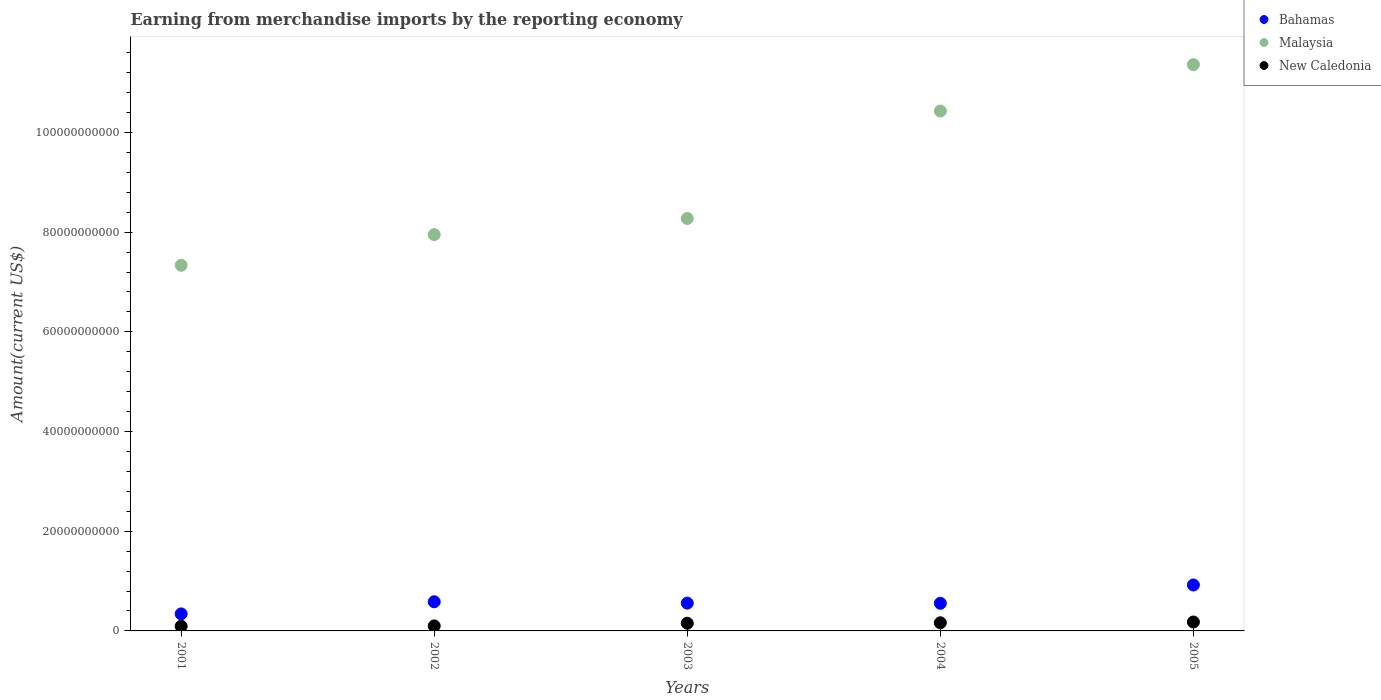Is the number of dotlines equal to the number of legend labels?
Make the answer very short. Yes. What is the amount earned from merchandise imports in New Caledonia in 2002?
Your response must be concise. 1.01e+09. Across all years, what is the maximum amount earned from merchandise imports in Bahamas?
Make the answer very short. 9.22e+09. Across all years, what is the minimum amount earned from merchandise imports in Bahamas?
Make the answer very short. 3.42e+09. In which year was the amount earned from merchandise imports in Bahamas maximum?
Provide a short and direct response. 2005. In which year was the amount earned from merchandise imports in Malaysia minimum?
Offer a very short reply. 2001. What is the total amount earned from merchandise imports in New Caledonia in the graph?
Your answer should be very brief. 6.91e+09. What is the difference between the amount earned from merchandise imports in Malaysia in 2001 and that in 2004?
Provide a succinct answer. -3.09e+1. What is the difference between the amount earned from merchandise imports in New Caledonia in 2002 and the amount earned from merchandise imports in Malaysia in 2003?
Your answer should be very brief. -8.17e+1. What is the average amount earned from merchandise imports in Malaysia per year?
Your response must be concise. 9.07e+1. In the year 2005, what is the difference between the amount earned from merchandise imports in Bahamas and amount earned from merchandise imports in New Caledonia?
Give a very brief answer. 7.43e+09. In how many years, is the amount earned from merchandise imports in Bahamas greater than 104000000000 US$?
Your answer should be compact. 0. What is the ratio of the amount earned from merchandise imports in Malaysia in 2002 to that in 2005?
Ensure brevity in your answer.  0.7. Is the amount earned from merchandise imports in Bahamas in 2003 less than that in 2004?
Your response must be concise. No. Is the difference between the amount earned from merchandise imports in Bahamas in 2003 and 2004 greater than the difference between the amount earned from merchandise imports in New Caledonia in 2003 and 2004?
Provide a short and direct response. Yes. What is the difference between the highest and the second highest amount earned from merchandise imports in Malaysia?
Provide a succinct answer. 9.30e+09. What is the difference between the highest and the lowest amount earned from merchandise imports in New Caledonia?
Your response must be concise. 8.58e+08. In how many years, is the amount earned from merchandise imports in New Caledonia greater than the average amount earned from merchandise imports in New Caledonia taken over all years?
Offer a very short reply. 3. Is the sum of the amount earned from merchandise imports in New Caledonia in 2003 and 2005 greater than the maximum amount earned from merchandise imports in Malaysia across all years?
Keep it short and to the point. No. Is it the case that in every year, the sum of the amount earned from merchandise imports in Bahamas and amount earned from merchandise imports in Malaysia  is greater than the amount earned from merchandise imports in New Caledonia?
Ensure brevity in your answer.  Yes. Does the amount earned from merchandise imports in New Caledonia monotonically increase over the years?
Give a very brief answer. Yes. How many years are there in the graph?
Ensure brevity in your answer.  5. Does the graph contain any zero values?
Your answer should be very brief. No. Does the graph contain grids?
Your answer should be very brief. No. What is the title of the graph?
Your answer should be very brief. Earning from merchandise imports by the reporting economy. Does "Gabon" appear as one of the legend labels in the graph?
Ensure brevity in your answer.  No. What is the label or title of the X-axis?
Your response must be concise. Years. What is the label or title of the Y-axis?
Make the answer very short. Amount(current US$). What is the Amount(current US$) of Bahamas in 2001?
Give a very brief answer. 3.42e+09. What is the Amount(current US$) in Malaysia in 2001?
Ensure brevity in your answer.  7.34e+1. What is the Amount(current US$) of New Caledonia in 2001?
Offer a very short reply. 9.31e+08. What is the Amount(current US$) in Bahamas in 2002?
Give a very brief answer. 5.85e+09. What is the Amount(current US$) in Malaysia in 2002?
Provide a succinct answer. 7.95e+1. What is the Amount(current US$) in New Caledonia in 2002?
Offer a terse response. 1.01e+09. What is the Amount(current US$) in Bahamas in 2003?
Make the answer very short. 5.58e+09. What is the Amount(current US$) of Malaysia in 2003?
Your response must be concise. 8.27e+1. What is the Amount(current US$) of New Caledonia in 2003?
Give a very brief answer. 1.54e+09. What is the Amount(current US$) of Bahamas in 2004?
Provide a short and direct response. 5.54e+09. What is the Amount(current US$) of Malaysia in 2004?
Give a very brief answer. 1.04e+11. What is the Amount(current US$) in New Caledonia in 2004?
Keep it short and to the point. 1.64e+09. What is the Amount(current US$) of Bahamas in 2005?
Offer a terse response. 9.22e+09. What is the Amount(current US$) in Malaysia in 2005?
Your answer should be compact. 1.14e+11. What is the Amount(current US$) in New Caledonia in 2005?
Your answer should be compact. 1.79e+09. Across all years, what is the maximum Amount(current US$) in Bahamas?
Provide a short and direct response. 9.22e+09. Across all years, what is the maximum Amount(current US$) of Malaysia?
Your answer should be compact. 1.14e+11. Across all years, what is the maximum Amount(current US$) of New Caledonia?
Your answer should be very brief. 1.79e+09. Across all years, what is the minimum Amount(current US$) of Bahamas?
Give a very brief answer. 3.42e+09. Across all years, what is the minimum Amount(current US$) in Malaysia?
Your response must be concise. 7.34e+1. Across all years, what is the minimum Amount(current US$) of New Caledonia?
Keep it short and to the point. 9.31e+08. What is the total Amount(current US$) of Bahamas in the graph?
Make the answer very short. 2.96e+1. What is the total Amount(current US$) of Malaysia in the graph?
Make the answer very short. 4.54e+11. What is the total Amount(current US$) in New Caledonia in the graph?
Provide a short and direct response. 6.91e+09. What is the difference between the Amount(current US$) in Bahamas in 2001 and that in 2002?
Your answer should be compact. -2.44e+09. What is the difference between the Amount(current US$) in Malaysia in 2001 and that in 2002?
Provide a succinct answer. -6.15e+09. What is the difference between the Amount(current US$) in New Caledonia in 2001 and that in 2002?
Offer a very short reply. -7.61e+07. What is the difference between the Amount(current US$) in Bahamas in 2001 and that in 2003?
Offer a very short reply. -2.16e+09. What is the difference between the Amount(current US$) in Malaysia in 2001 and that in 2003?
Ensure brevity in your answer.  -9.38e+09. What is the difference between the Amount(current US$) in New Caledonia in 2001 and that in 2003?
Your answer should be very brief. -6.10e+08. What is the difference between the Amount(current US$) in Bahamas in 2001 and that in 2004?
Your response must be concise. -2.13e+09. What is the difference between the Amount(current US$) in Malaysia in 2001 and that in 2004?
Your answer should be compact. -3.09e+1. What is the difference between the Amount(current US$) of New Caledonia in 2001 and that in 2004?
Make the answer very short. -7.05e+08. What is the difference between the Amount(current US$) in Bahamas in 2001 and that in 2005?
Your answer should be compact. -5.80e+09. What is the difference between the Amount(current US$) in Malaysia in 2001 and that in 2005?
Keep it short and to the point. -4.02e+1. What is the difference between the Amount(current US$) of New Caledonia in 2001 and that in 2005?
Ensure brevity in your answer.  -8.58e+08. What is the difference between the Amount(current US$) of Bahamas in 2002 and that in 2003?
Your response must be concise. 2.76e+08. What is the difference between the Amount(current US$) of Malaysia in 2002 and that in 2003?
Your answer should be very brief. -3.23e+09. What is the difference between the Amount(current US$) in New Caledonia in 2002 and that in 2003?
Provide a short and direct response. -5.34e+08. What is the difference between the Amount(current US$) in Bahamas in 2002 and that in 2004?
Keep it short and to the point. 3.09e+08. What is the difference between the Amount(current US$) in Malaysia in 2002 and that in 2004?
Provide a short and direct response. -2.48e+1. What is the difference between the Amount(current US$) in New Caledonia in 2002 and that in 2004?
Ensure brevity in your answer.  -6.29e+08. What is the difference between the Amount(current US$) of Bahamas in 2002 and that in 2005?
Make the answer very short. -3.37e+09. What is the difference between the Amount(current US$) in Malaysia in 2002 and that in 2005?
Offer a very short reply. -3.41e+1. What is the difference between the Amount(current US$) of New Caledonia in 2002 and that in 2005?
Make the answer very short. -7.82e+08. What is the difference between the Amount(current US$) of Bahamas in 2003 and that in 2004?
Offer a terse response. 3.35e+07. What is the difference between the Amount(current US$) of Malaysia in 2003 and that in 2004?
Your answer should be compact. -2.16e+1. What is the difference between the Amount(current US$) of New Caledonia in 2003 and that in 2004?
Ensure brevity in your answer.  -9.53e+07. What is the difference between the Amount(current US$) in Bahamas in 2003 and that in 2005?
Provide a short and direct response. -3.64e+09. What is the difference between the Amount(current US$) in Malaysia in 2003 and that in 2005?
Offer a terse response. -3.09e+1. What is the difference between the Amount(current US$) of New Caledonia in 2003 and that in 2005?
Provide a short and direct response. -2.48e+08. What is the difference between the Amount(current US$) in Bahamas in 2004 and that in 2005?
Your response must be concise. -3.67e+09. What is the difference between the Amount(current US$) of Malaysia in 2004 and that in 2005?
Offer a very short reply. -9.30e+09. What is the difference between the Amount(current US$) of New Caledonia in 2004 and that in 2005?
Give a very brief answer. -1.53e+08. What is the difference between the Amount(current US$) in Bahamas in 2001 and the Amount(current US$) in Malaysia in 2002?
Provide a succinct answer. -7.61e+1. What is the difference between the Amount(current US$) in Bahamas in 2001 and the Amount(current US$) in New Caledonia in 2002?
Keep it short and to the point. 2.41e+09. What is the difference between the Amount(current US$) of Malaysia in 2001 and the Amount(current US$) of New Caledonia in 2002?
Your answer should be compact. 7.24e+1. What is the difference between the Amount(current US$) in Bahamas in 2001 and the Amount(current US$) in Malaysia in 2003?
Ensure brevity in your answer.  -7.93e+1. What is the difference between the Amount(current US$) in Bahamas in 2001 and the Amount(current US$) in New Caledonia in 2003?
Your answer should be very brief. 1.87e+09. What is the difference between the Amount(current US$) in Malaysia in 2001 and the Amount(current US$) in New Caledonia in 2003?
Keep it short and to the point. 7.18e+1. What is the difference between the Amount(current US$) in Bahamas in 2001 and the Amount(current US$) in Malaysia in 2004?
Provide a short and direct response. -1.01e+11. What is the difference between the Amount(current US$) of Bahamas in 2001 and the Amount(current US$) of New Caledonia in 2004?
Your answer should be very brief. 1.78e+09. What is the difference between the Amount(current US$) in Malaysia in 2001 and the Amount(current US$) in New Caledonia in 2004?
Give a very brief answer. 7.17e+1. What is the difference between the Amount(current US$) of Bahamas in 2001 and the Amount(current US$) of Malaysia in 2005?
Provide a succinct answer. -1.10e+11. What is the difference between the Amount(current US$) in Bahamas in 2001 and the Amount(current US$) in New Caledonia in 2005?
Your answer should be very brief. 1.63e+09. What is the difference between the Amount(current US$) of Malaysia in 2001 and the Amount(current US$) of New Caledonia in 2005?
Keep it short and to the point. 7.16e+1. What is the difference between the Amount(current US$) in Bahamas in 2002 and the Amount(current US$) in Malaysia in 2003?
Keep it short and to the point. -7.69e+1. What is the difference between the Amount(current US$) of Bahamas in 2002 and the Amount(current US$) of New Caledonia in 2003?
Offer a very short reply. 4.31e+09. What is the difference between the Amount(current US$) of Malaysia in 2002 and the Amount(current US$) of New Caledonia in 2003?
Offer a very short reply. 7.80e+1. What is the difference between the Amount(current US$) of Bahamas in 2002 and the Amount(current US$) of Malaysia in 2004?
Ensure brevity in your answer.  -9.85e+1. What is the difference between the Amount(current US$) in Bahamas in 2002 and the Amount(current US$) in New Caledonia in 2004?
Your answer should be compact. 4.22e+09. What is the difference between the Amount(current US$) in Malaysia in 2002 and the Amount(current US$) in New Caledonia in 2004?
Keep it short and to the point. 7.79e+1. What is the difference between the Amount(current US$) of Bahamas in 2002 and the Amount(current US$) of Malaysia in 2005?
Keep it short and to the point. -1.08e+11. What is the difference between the Amount(current US$) of Bahamas in 2002 and the Amount(current US$) of New Caledonia in 2005?
Your answer should be compact. 4.06e+09. What is the difference between the Amount(current US$) of Malaysia in 2002 and the Amount(current US$) of New Caledonia in 2005?
Your answer should be very brief. 7.77e+1. What is the difference between the Amount(current US$) of Bahamas in 2003 and the Amount(current US$) of Malaysia in 2004?
Offer a terse response. -9.87e+1. What is the difference between the Amount(current US$) in Bahamas in 2003 and the Amount(current US$) in New Caledonia in 2004?
Keep it short and to the point. 3.94e+09. What is the difference between the Amount(current US$) of Malaysia in 2003 and the Amount(current US$) of New Caledonia in 2004?
Offer a very short reply. 8.11e+1. What is the difference between the Amount(current US$) in Bahamas in 2003 and the Amount(current US$) in Malaysia in 2005?
Your answer should be very brief. -1.08e+11. What is the difference between the Amount(current US$) in Bahamas in 2003 and the Amount(current US$) in New Caledonia in 2005?
Keep it short and to the point. 3.79e+09. What is the difference between the Amount(current US$) in Malaysia in 2003 and the Amount(current US$) in New Caledonia in 2005?
Provide a succinct answer. 8.10e+1. What is the difference between the Amount(current US$) in Bahamas in 2004 and the Amount(current US$) in Malaysia in 2005?
Ensure brevity in your answer.  -1.08e+11. What is the difference between the Amount(current US$) of Bahamas in 2004 and the Amount(current US$) of New Caledonia in 2005?
Give a very brief answer. 3.75e+09. What is the difference between the Amount(current US$) in Malaysia in 2004 and the Amount(current US$) in New Caledonia in 2005?
Your answer should be compact. 1.03e+11. What is the average Amount(current US$) of Bahamas per year?
Offer a very short reply. 5.92e+09. What is the average Amount(current US$) in Malaysia per year?
Make the answer very short. 9.07e+1. What is the average Amount(current US$) of New Caledonia per year?
Make the answer very short. 1.38e+09. In the year 2001, what is the difference between the Amount(current US$) in Bahamas and Amount(current US$) in Malaysia?
Provide a short and direct response. -6.99e+1. In the year 2001, what is the difference between the Amount(current US$) of Bahamas and Amount(current US$) of New Caledonia?
Provide a short and direct response. 2.48e+09. In the year 2001, what is the difference between the Amount(current US$) in Malaysia and Amount(current US$) in New Caledonia?
Give a very brief answer. 7.24e+1. In the year 2002, what is the difference between the Amount(current US$) in Bahamas and Amount(current US$) in Malaysia?
Your response must be concise. -7.37e+1. In the year 2002, what is the difference between the Amount(current US$) in Bahamas and Amount(current US$) in New Caledonia?
Offer a very short reply. 4.84e+09. In the year 2002, what is the difference between the Amount(current US$) in Malaysia and Amount(current US$) in New Caledonia?
Offer a terse response. 7.85e+1. In the year 2003, what is the difference between the Amount(current US$) of Bahamas and Amount(current US$) of Malaysia?
Offer a terse response. -7.72e+1. In the year 2003, what is the difference between the Amount(current US$) of Bahamas and Amount(current US$) of New Caledonia?
Keep it short and to the point. 4.03e+09. In the year 2003, what is the difference between the Amount(current US$) in Malaysia and Amount(current US$) in New Caledonia?
Your response must be concise. 8.12e+1. In the year 2004, what is the difference between the Amount(current US$) in Bahamas and Amount(current US$) in Malaysia?
Ensure brevity in your answer.  -9.88e+1. In the year 2004, what is the difference between the Amount(current US$) in Bahamas and Amount(current US$) in New Caledonia?
Offer a very short reply. 3.91e+09. In the year 2004, what is the difference between the Amount(current US$) in Malaysia and Amount(current US$) in New Caledonia?
Keep it short and to the point. 1.03e+11. In the year 2005, what is the difference between the Amount(current US$) of Bahamas and Amount(current US$) of Malaysia?
Provide a succinct answer. -1.04e+11. In the year 2005, what is the difference between the Amount(current US$) in Bahamas and Amount(current US$) in New Caledonia?
Offer a very short reply. 7.43e+09. In the year 2005, what is the difference between the Amount(current US$) of Malaysia and Amount(current US$) of New Caledonia?
Provide a short and direct response. 1.12e+11. What is the ratio of the Amount(current US$) of Bahamas in 2001 to that in 2002?
Your answer should be very brief. 0.58. What is the ratio of the Amount(current US$) of Malaysia in 2001 to that in 2002?
Your answer should be very brief. 0.92. What is the ratio of the Amount(current US$) of New Caledonia in 2001 to that in 2002?
Give a very brief answer. 0.92. What is the ratio of the Amount(current US$) in Bahamas in 2001 to that in 2003?
Keep it short and to the point. 0.61. What is the ratio of the Amount(current US$) in Malaysia in 2001 to that in 2003?
Ensure brevity in your answer.  0.89. What is the ratio of the Amount(current US$) in New Caledonia in 2001 to that in 2003?
Provide a succinct answer. 0.6. What is the ratio of the Amount(current US$) in Bahamas in 2001 to that in 2004?
Offer a very short reply. 0.62. What is the ratio of the Amount(current US$) in Malaysia in 2001 to that in 2004?
Provide a succinct answer. 0.7. What is the ratio of the Amount(current US$) in New Caledonia in 2001 to that in 2004?
Ensure brevity in your answer.  0.57. What is the ratio of the Amount(current US$) in Bahamas in 2001 to that in 2005?
Offer a terse response. 0.37. What is the ratio of the Amount(current US$) in Malaysia in 2001 to that in 2005?
Offer a very short reply. 0.65. What is the ratio of the Amount(current US$) in New Caledonia in 2001 to that in 2005?
Give a very brief answer. 0.52. What is the ratio of the Amount(current US$) in Bahamas in 2002 to that in 2003?
Your response must be concise. 1.05. What is the ratio of the Amount(current US$) in New Caledonia in 2002 to that in 2003?
Provide a succinct answer. 0.65. What is the ratio of the Amount(current US$) in Bahamas in 2002 to that in 2004?
Provide a short and direct response. 1.06. What is the ratio of the Amount(current US$) of Malaysia in 2002 to that in 2004?
Give a very brief answer. 0.76. What is the ratio of the Amount(current US$) of New Caledonia in 2002 to that in 2004?
Offer a very short reply. 0.62. What is the ratio of the Amount(current US$) in Bahamas in 2002 to that in 2005?
Offer a terse response. 0.63. What is the ratio of the Amount(current US$) in Malaysia in 2002 to that in 2005?
Your answer should be very brief. 0.7. What is the ratio of the Amount(current US$) in New Caledonia in 2002 to that in 2005?
Provide a succinct answer. 0.56. What is the ratio of the Amount(current US$) of Malaysia in 2003 to that in 2004?
Your response must be concise. 0.79. What is the ratio of the Amount(current US$) of New Caledonia in 2003 to that in 2004?
Make the answer very short. 0.94. What is the ratio of the Amount(current US$) in Bahamas in 2003 to that in 2005?
Offer a very short reply. 0.6. What is the ratio of the Amount(current US$) in Malaysia in 2003 to that in 2005?
Your response must be concise. 0.73. What is the ratio of the Amount(current US$) of New Caledonia in 2003 to that in 2005?
Offer a terse response. 0.86. What is the ratio of the Amount(current US$) of Bahamas in 2004 to that in 2005?
Provide a succinct answer. 0.6. What is the ratio of the Amount(current US$) in Malaysia in 2004 to that in 2005?
Give a very brief answer. 0.92. What is the ratio of the Amount(current US$) in New Caledonia in 2004 to that in 2005?
Provide a short and direct response. 0.91. What is the difference between the highest and the second highest Amount(current US$) in Bahamas?
Provide a succinct answer. 3.37e+09. What is the difference between the highest and the second highest Amount(current US$) of Malaysia?
Offer a terse response. 9.30e+09. What is the difference between the highest and the second highest Amount(current US$) in New Caledonia?
Provide a short and direct response. 1.53e+08. What is the difference between the highest and the lowest Amount(current US$) in Bahamas?
Your answer should be compact. 5.80e+09. What is the difference between the highest and the lowest Amount(current US$) of Malaysia?
Your response must be concise. 4.02e+1. What is the difference between the highest and the lowest Amount(current US$) of New Caledonia?
Keep it short and to the point. 8.58e+08. 